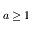<formula> <loc_0><loc_0><loc_500><loc_500>a \geq 1</formula> 